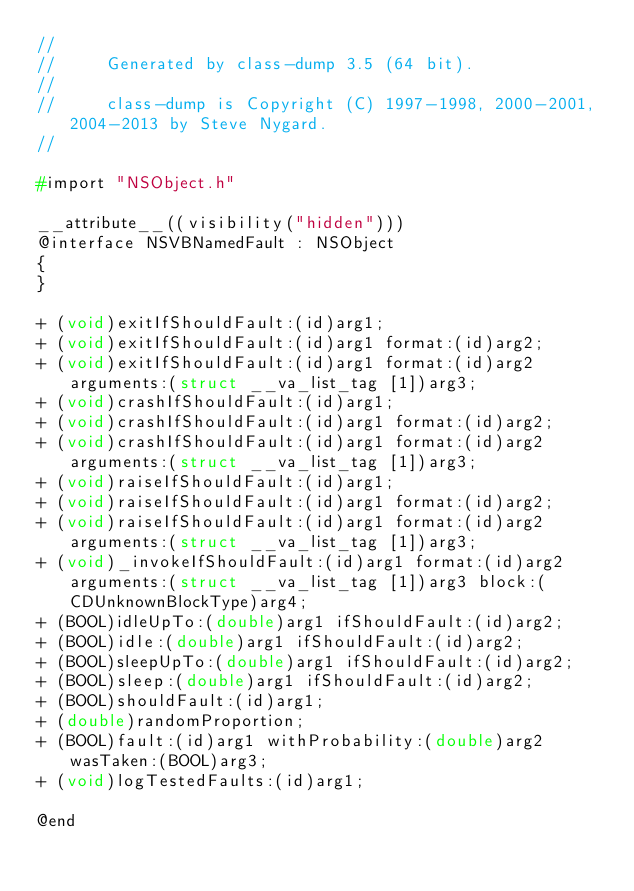Convert code to text. <code><loc_0><loc_0><loc_500><loc_500><_C_>//
//     Generated by class-dump 3.5 (64 bit).
//
//     class-dump is Copyright (C) 1997-1998, 2000-2001, 2004-2013 by Steve Nygard.
//

#import "NSObject.h"

__attribute__((visibility("hidden")))
@interface NSVBNamedFault : NSObject
{
}

+ (void)exitIfShouldFault:(id)arg1;
+ (void)exitIfShouldFault:(id)arg1 format:(id)arg2;
+ (void)exitIfShouldFault:(id)arg1 format:(id)arg2 arguments:(struct __va_list_tag [1])arg3;
+ (void)crashIfShouldFault:(id)arg1;
+ (void)crashIfShouldFault:(id)arg1 format:(id)arg2;
+ (void)crashIfShouldFault:(id)arg1 format:(id)arg2 arguments:(struct __va_list_tag [1])arg3;
+ (void)raiseIfShouldFault:(id)arg1;
+ (void)raiseIfShouldFault:(id)arg1 format:(id)arg2;
+ (void)raiseIfShouldFault:(id)arg1 format:(id)arg2 arguments:(struct __va_list_tag [1])arg3;
+ (void)_invokeIfShouldFault:(id)arg1 format:(id)arg2 arguments:(struct __va_list_tag [1])arg3 block:(CDUnknownBlockType)arg4;
+ (BOOL)idleUpTo:(double)arg1 ifShouldFault:(id)arg2;
+ (BOOL)idle:(double)arg1 ifShouldFault:(id)arg2;
+ (BOOL)sleepUpTo:(double)arg1 ifShouldFault:(id)arg2;
+ (BOOL)sleep:(double)arg1 ifShouldFault:(id)arg2;
+ (BOOL)shouldFault:(id)arg1;
+ (double)randomProportion;
+ (BOOL)fault:(id)arg1 withProbability:(double)arg2 wasTaken:(BOOL)arg3;
+ (void)logTestedFaults:(id)arg1;

@end

</code> 